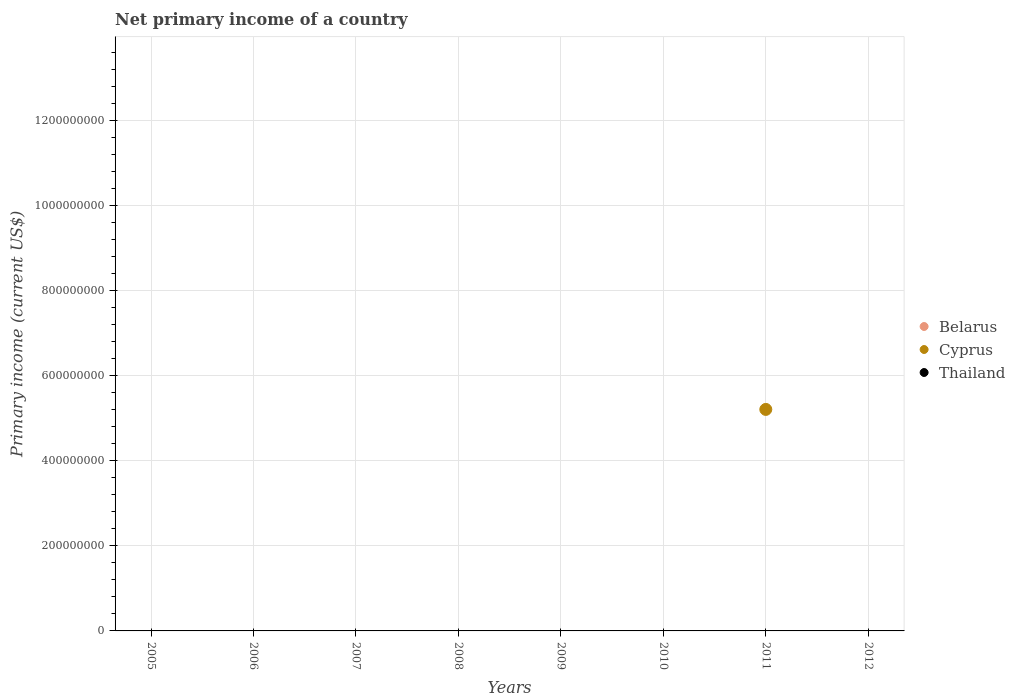How many different coloured dotlines are there?
Offer a terse response. 1. What is the primary income in Thailand in 2012?
Offer a terse response. 0. Across all years, what is the maximum primary income in Cyprus?
Your answer should be compact. 5.21e+08. Across all years, what is the minimum primary income in Cyprus?
Your answer should be very brief. 0. In which year was the primary income in Cyprus maximum?
Offer a terse response. 2011. What is the average primary income in Cyprus per year?
Make the answer very short. 6.51e+07. In how many years, is the primary income in Thailand greater than 720000000 US$?
Offer a terse response. 0. What is the difference between the highest and the lowest primary income in Cyprus?
Offer a very short reply. 5.21e+08. Is it the case that in every year, the sum of the primary income in Thailand and primary income in Cyprus  is greater than the primary income in Belarus?
Offer a terse response. No. Is the primary income in Thailand strictly greater than the primary income in Belarus over the years?
Provide a succinct answer. No. How many dotlines are there?
Your answer should be very brief. 1. How many years are there in the graph?
Your response must be concise. 8. Are the values on the major ticks of Y-axis written in scientific E-notation?
Your response must be concise. No. Where does the legend appear in the graph?
Your response must be concise. Center right. How many legend labels are there?
Your answer should be compact. 3. What is the title of the graph?
Give a very brief answer. Net primary income of a country. What is the label or title of the Y-axis?
Make the answer very short. Primary income (current US$). What is the Primary income (current US$) in Cyprus in 2005?
Provide a short and direct response. 0. What is the Primary income (current US$) in Belarus in 2006?
Offer a terse response. 0. What is the Primary income (current US$) in Thailand in 2006?
Keep it short and to the point. 0. What is the Primary income (current US$) of Thailand in 2007?
Keep it short and to the point. 0. What is the Primary income (current US$) in Belarus in 2008?
Provide a succinct answer. 0. What is the Primary income (current US$) in Thailand in 2008?
Make the answer very short. 0. What is the Primary income (current US$) in Belarus in 2009?
Provide a short and direct response. 0. What is the Primary income (current US$) in Thailand in 2009?
Offer a very short reply. 0. What is the Primary income (current US$) of Belarus in 2010?
Offer a very short reply. 0. What is the Primary income (current US$) in Cyprus in 2010?
Your response must be concise. 0. What is the Primary income (current US$) of Belarus in 2011?
Provide a succinct answer. 0. What is the Primary income (current US$) in Cyprus in 2011?
Offer a very short reply. 5.21e+08. What is the Primary income (current US$) in Thailand in 2011?
Your answer should be compact. 0. What is the Primary income (current US$) in Cyprus in 2012?
Give a very brief answer. 0. Across all years, what is the maximum Primary income (current US$) of Cyprus?
Provide a short and direct response. 5.21e+08. Across all years, what is the minimum Primary income (current US$) in Cyprus?
Offer a terse response. 0. What is the total Primary income (current US$) of Belarus in the graph?
Give a very brief answer. 0. What is the total Primary income (current US$) of Cyprus in the graph?
Your response must be concise. 5.21e+08. What is the total Primary income (current US$) of Thailand in the graph?
Provide a short and direct response. 0. What is the average Primary income (current US$) of Cyprus per year?
Provide a short and direct response. 6.51e+07. What is the average Primary income (current US$) of Thailand per year?
Keep it short and to the point. 0. What is the difference between the highest and the lowest Primary income (current US$) in Cyprus?
Offer a terse response. 5.21e+08. 